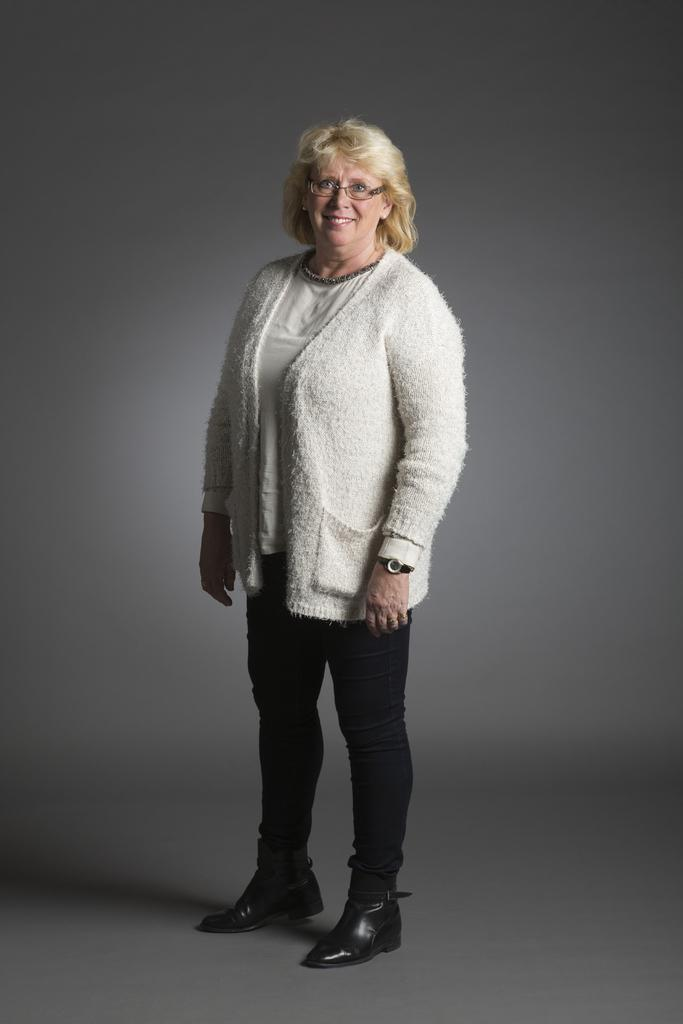What is the main subject of the image? There is a person in the image. What is the person doing in the image? The person is standing in the image. What expression does the person have? The person is smiling in the image. What type of home can be seen in the background of the image? There is no home visible in the image; it only features a person standing and smiling. How many knees does the person have in the image? The person in the image has two knees, but the number of knees is not visible in the image. 